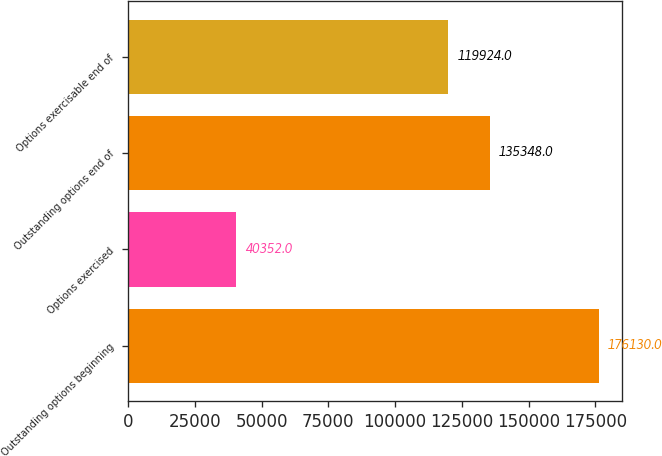<chart> <loc_0><loc_0><loc_500><loc_500><bar_chart><fcel>Outstanding options beginning<fcel>Options exercised<fcel>Outstanding options end of<fcel>Options exercisable end of<nl><fcel>176130<fcel>40352<fcel>135348<fcel>119924<nl></chart> 